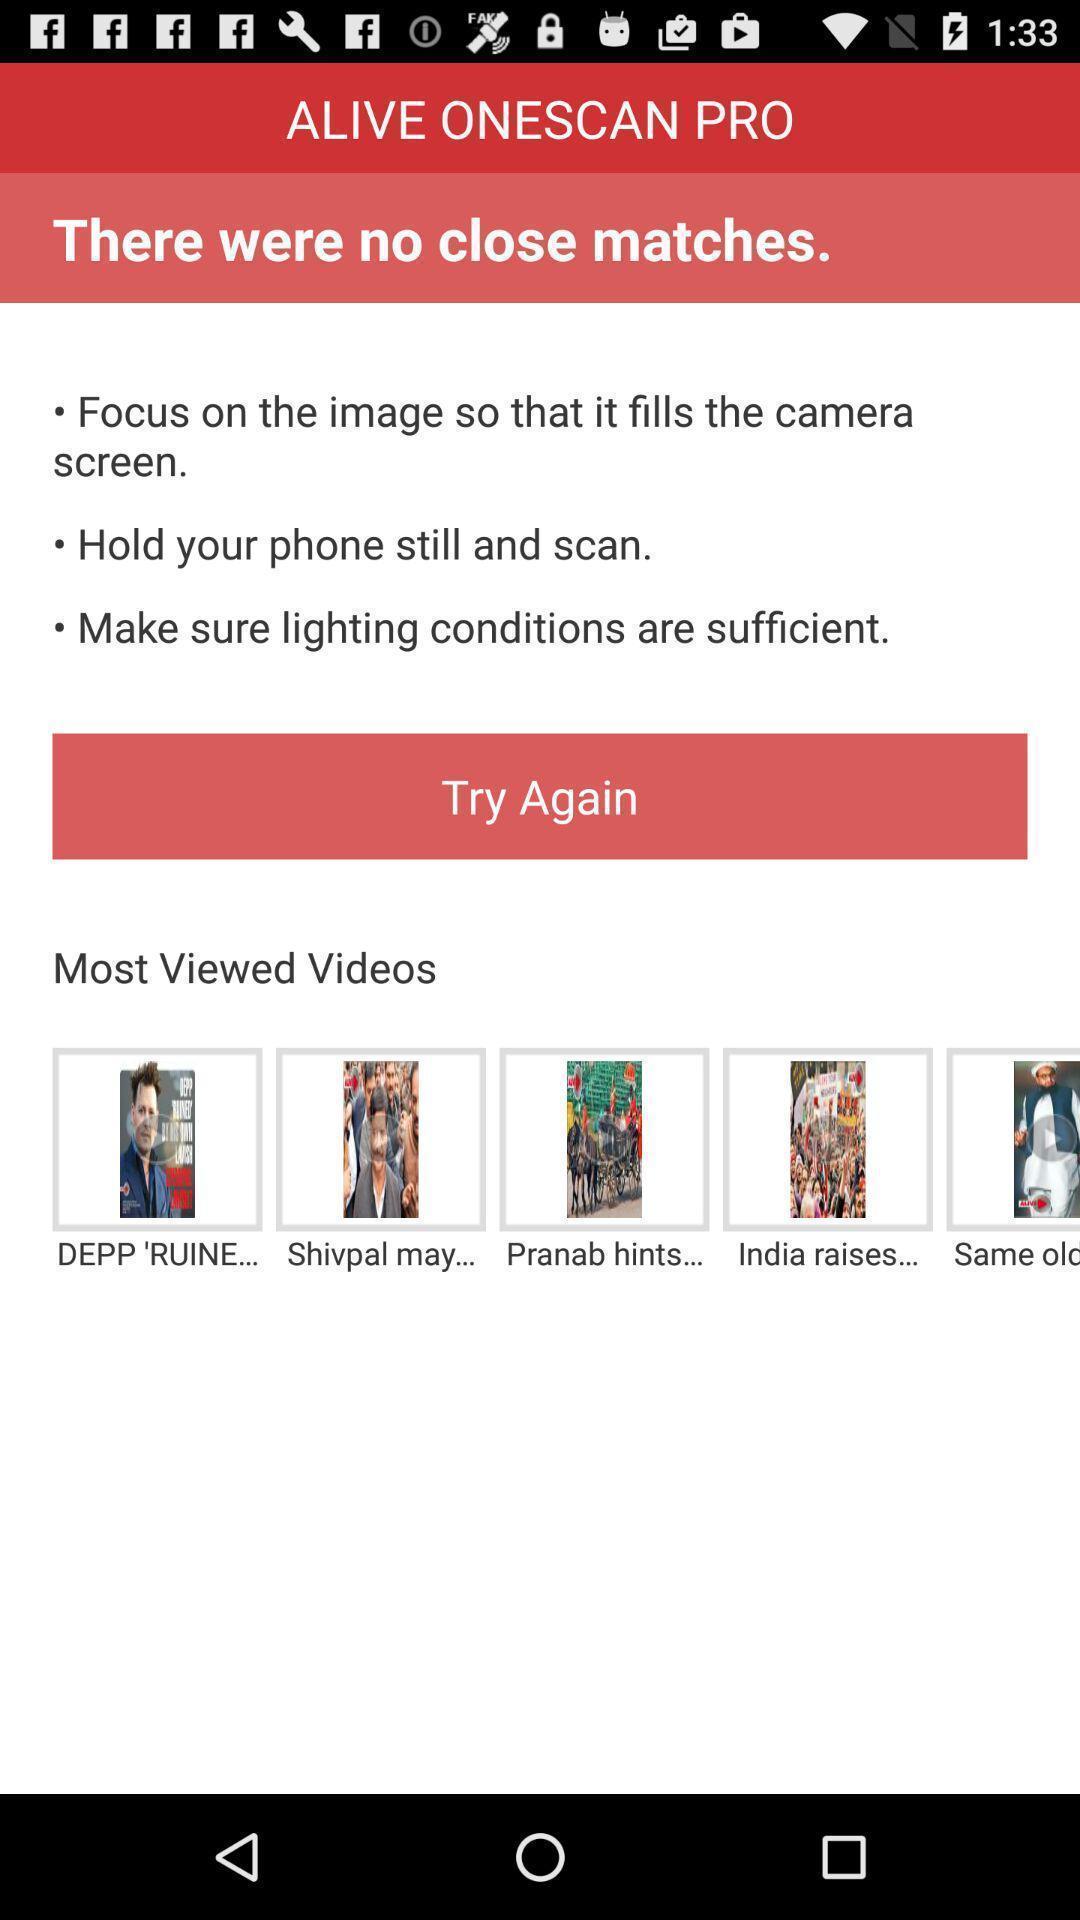Describe the visual elements of this screenshot. Screen page displaying various videos. 